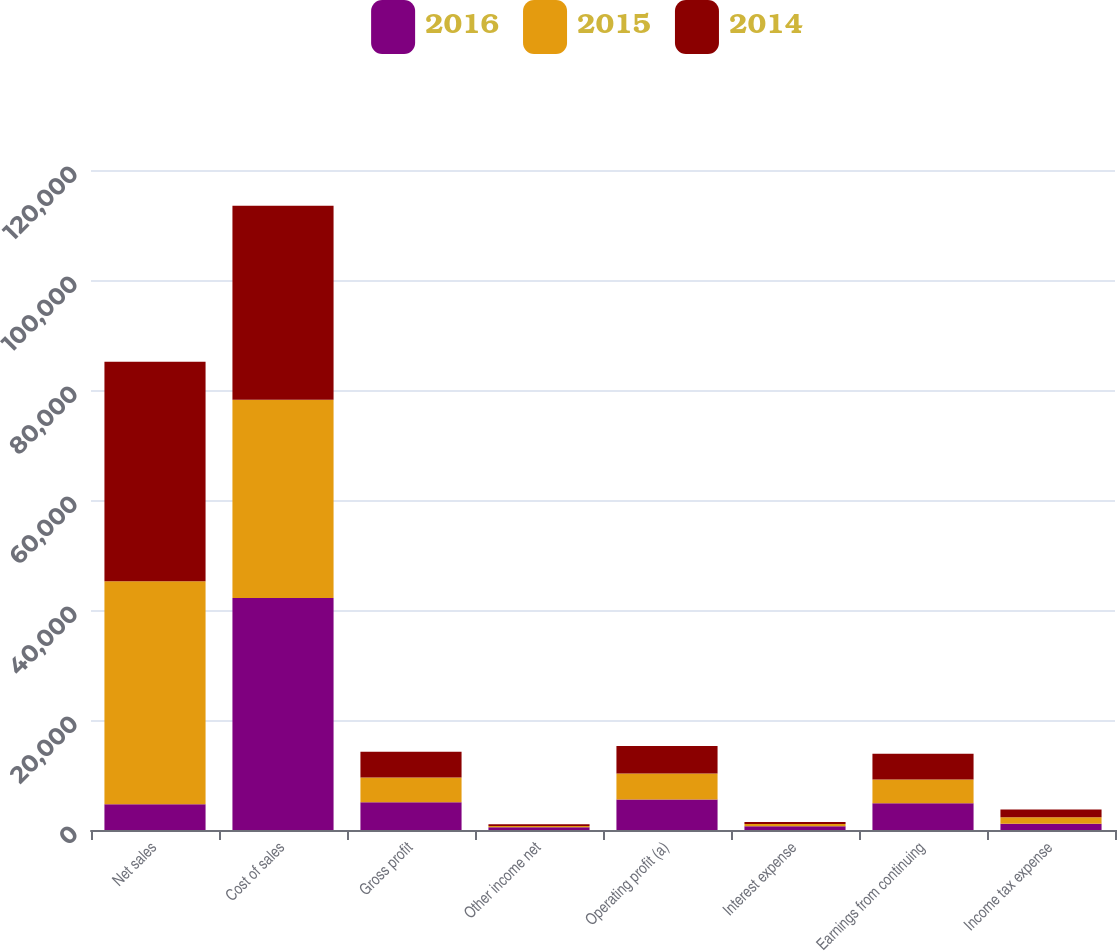Convert chart to OTSL. <chart><loc_0><loc_0><loc_500><loc_500><stacked_bar_chart><ecel><fcel>Net sales<fcel>Cost of sales<fcel>Gross profit<fcel>Other income net<fcel>Operating profit (a)<fcel>Interest expense<fcel>Earnings from continuing<fcel>Income tax expense<nl><fcel>2016<fcel>4677<fcel>42186<fcel>5062<fcel>487<fcel>5549<fcel>663<fcel>4886<fcel>1133<nl><fcel>2015<fcel>40536<fcel>36044<fcel>4492<fcel>220<fcel>4712<fcel>443<fcel>4299<fcel>1173<nl><fcel>2014<fcel>39946<fcel>35263<fcel>4683<fcel>329<fcel>5012<fcel>340<fcel>4677<fcel>1424<nl></chart> 